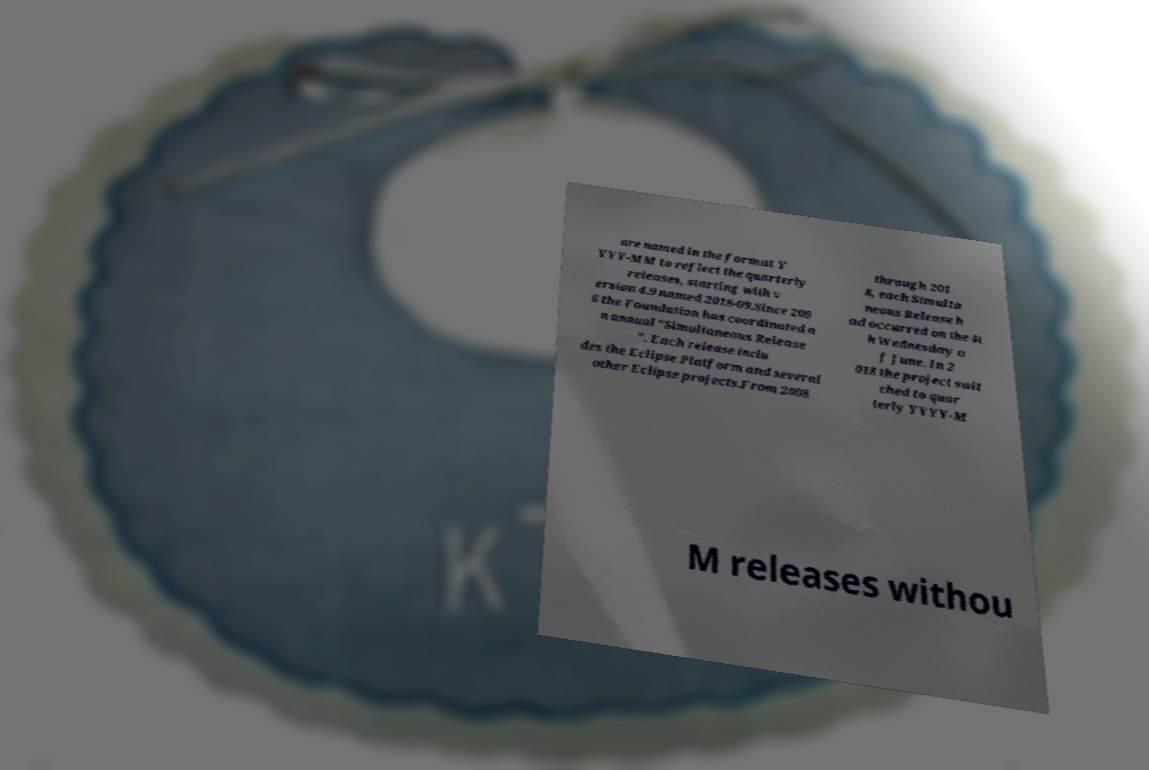Can you read and provide the text displayed in the image?This photo seems to have some interesting text. Can you extract and type it out for me? are named in the format Y YYY-MM to reflect the quarterly releases, starting with v ersion 4.9 named 2018-09.Since 200 6 the Foundation has coordinated a n annual "Simultaneous Release ". Each release inclu des the Eclipse Platform and several other Eclipse projects.From 2008 through 201 8, each Simulta neous Release h ad occurred on the 4t h Wednesday o f June. In 2 018 the project swit ched to quar terly YYYY-M M releases withou 